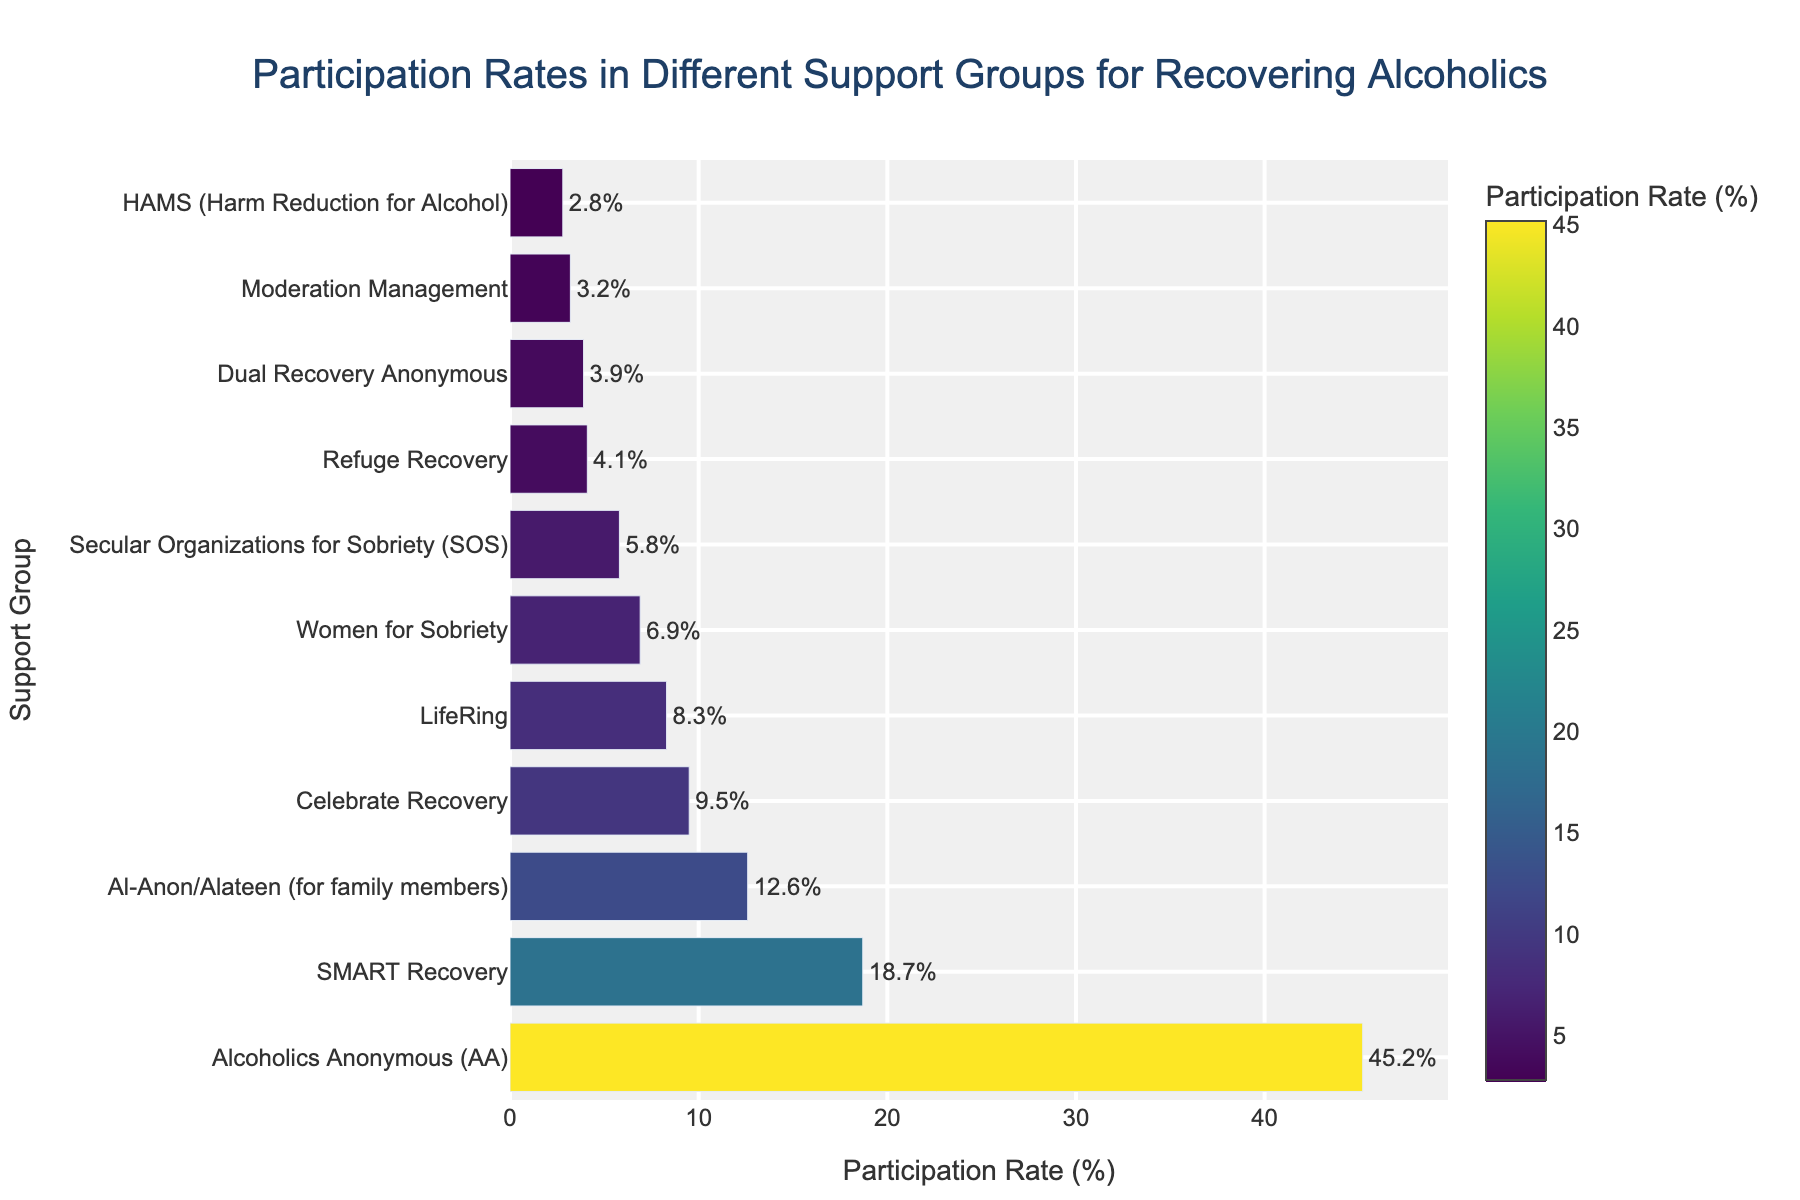Which support group has the highest participation rate? The bar chart shows the participation rates for each group, and the longest bar represents the highest rate. Alcoholics Anonymous (AA) has the longest bar.
Answer: Alcoholics Anonymous (AA) Which support group has the lowest participation rate? The shortest bar in the chart indicates the lowest participation rate. HAMS (Harm Reduction for Alcohol) has the shortest bar.
Answer: HAMS (Harm Reduction for Alcohol) What is the participation rate difference between Alcoholics Anonymous (AA) and SMART Recovery? The participation rate of Alcoholics Anonymous (AA) is 45.2%, and SMART Recovery is 18.7%. Subtract the latter from the former: 45.2 - 18.7 = 26.5%.
Answer: 26.5% Which group has a higher participation rate: Celebrate Recovery or LifeRing? Compare the lengths of the bars for Celebrate Recovery (9.5%) and LifeRing (8.3%). The bar for Celebrate Recovery is longer.
Answer: Celebrate Recovery What is the total participation rate for Women for Sobriety and Refuge Recovery combined? Add the participation rates of Women for Sobriety (6.9%) and Refuge Recovery (4.1%): 6.9 + 4.1 = 11%.
Answer: 11% How much higher is the participation rate for Al-Anon/Alateen compared to Moderation Management? The participation rate for Al-Anon/Alateen is 12.6%, and for Moderation Management, it is 3.2%. Subtract the latter from the former: 12.6 - 3.2 = 9.4%.
Answer: 9.4% Which group has the third highest participation rate? After Alcoholics Anonymous (AA) and SMART Recovery, the group with the next longest bar is Al-Anon/Alateen, which has a participation rate of 12.6%.
Answer: Al-Anon/Alateen (for family members) Which color on the chart corresponds to the participation rate of Dual Recovery Anonymous? Identify the bar for Dual Recovery Anonymous and observe its color. It is in the series of colors ranging from dark green to light yellow. Dual Recovery Anonymous has a participation rate of 3.9%, indicated by a mid-range yellow-green color.
Answer: Yellow-green What is the average participation rate of the three smallest groups in the chart? Identify the three smallest groups: HAMS (2.8%), Moderation Management (3.2%), and Dual Recovery Anonymous (3.9%). Calculate their average by summing the rates and dividing by three: (2.8 + 3.2 + 3.9) / 3 ≈ 3.3%.
Answer: 3.3% Which groups have a participation rate higher than the average rate of women-focused groups (Women for Sobriety and Al-Anon/Alateen)? First, calculate the average participation rate of Women for Sobriety (6.9%) and Al-Anon/Alateen (12.6%): (6.9 + 12.6) / 2 = 9.75%. Then, identify groups with rates higher than 9.75%: Alcoholics Anonymous (45.2%) and SMART Recovery (18.7%).
Answer: Alcoholics Anonymous (AA) and SMART Recovery 